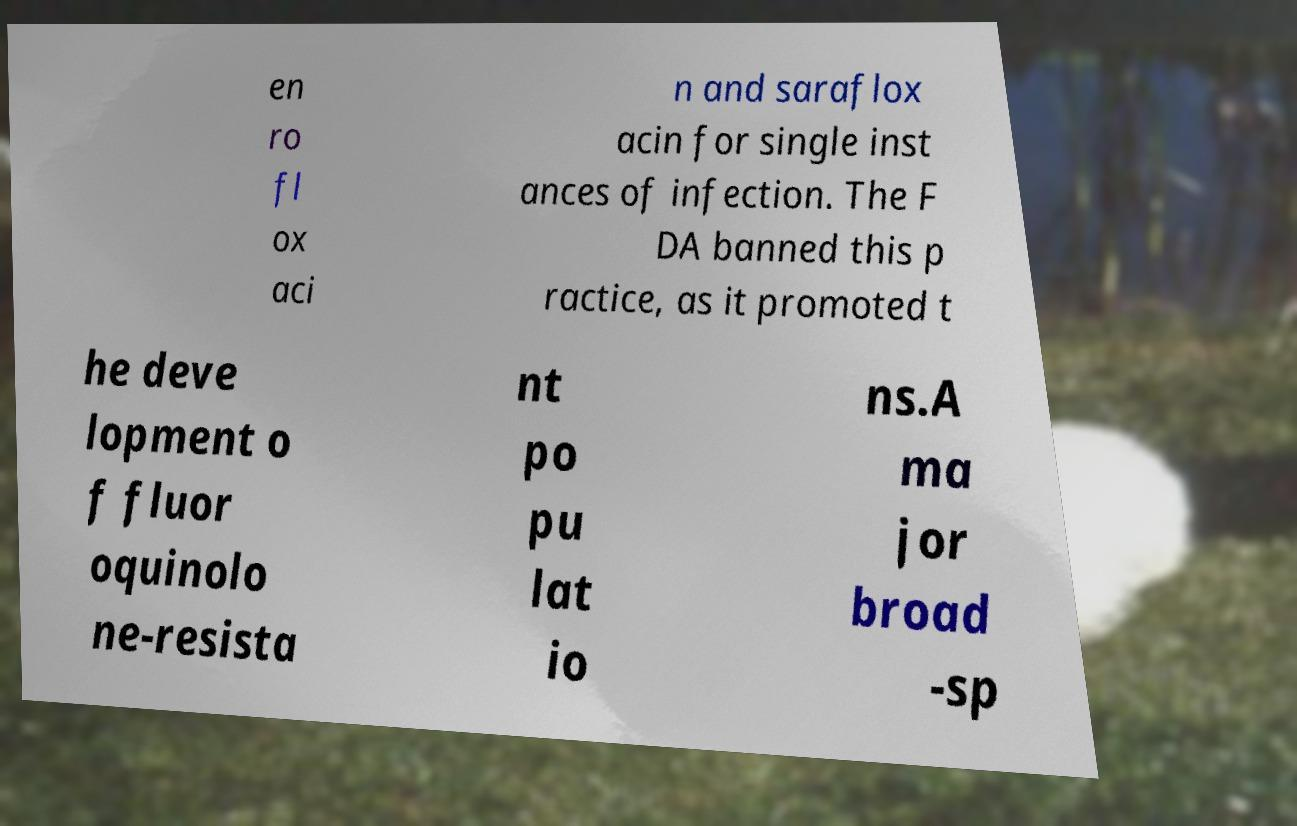Please identify and transcribe the text found in this image. en ro fl ox aci n and saraflox acin for single inst ances of infection. The F DA banned this p ractice, as it promoted t he deve lopment o f fluor oquinolo ne-resista nt po pu lat io ns.A ma jor broad -sp 